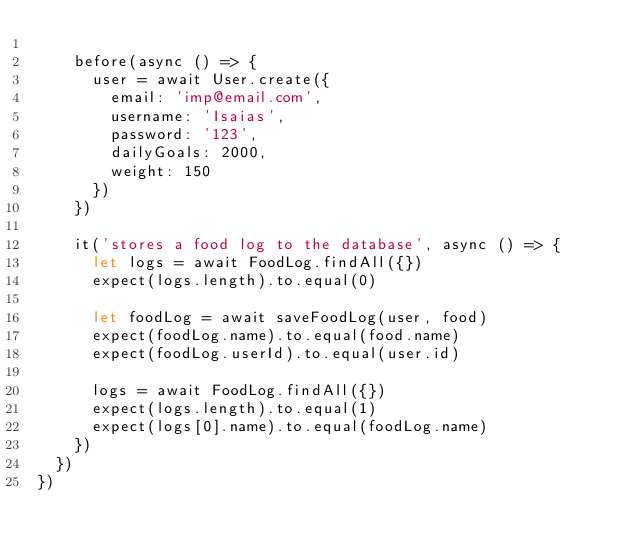Convert code to text. <code><loc_0><loc_0><loc_500><loc_500><_JavaScript_>
    before(async () => {
      user = await User.create({
        email: 'imp@email.com',
        username: 'Isaias',
        password: '123',
        dailyGoals: 2000,
        weight: 150
      })
    })

    it('stores a food log to the database', async () => {
      let logs = await FoodLog.findAll({})
      expect(logs.length).to.equal(0)

      let foodLog = await saveFoodLog(user, food)
      expect(foodLog.name).to.equal(food.name)
      expect(foodLog.userId).to.equal(user.id)

      logs = await FoodLog.findAll({})
      expect(logs.length).to.equal(1)
      expect(logs[0].name).to.equal(foodLog.name)
    })
  })
})
</code> 